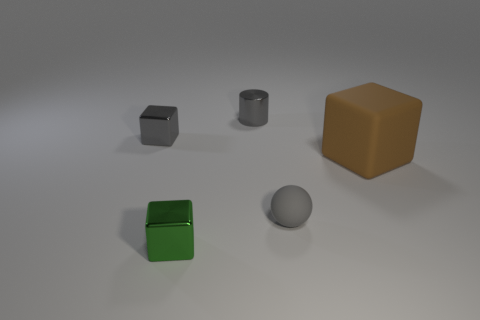Add 2 green matte balls. How many objects exist? 7 Subtract all cylinders. How many objects are left? 4 Add 3 tiny gray shiny balls. How many tiny gray shiny balls exist? 3 Subtract 0 brown spheres. How many objects are left? 5 Subtract all big gray shiny things. Subtract all metal blocks. How many objects are left? 3 Add 1 tiny green blocks. How many tiny green blocks are left? 2 